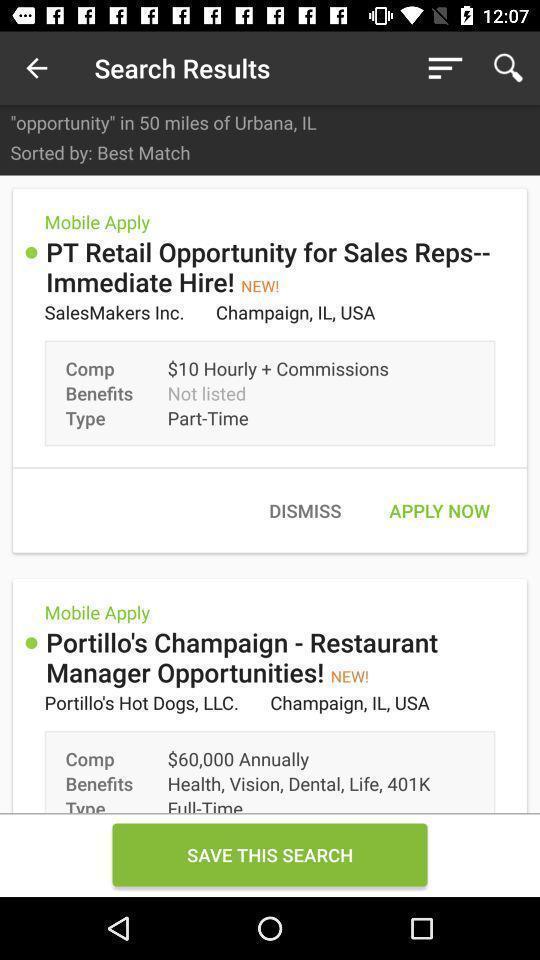Summarize the information in this screenshot. Window displaying a job search app. 